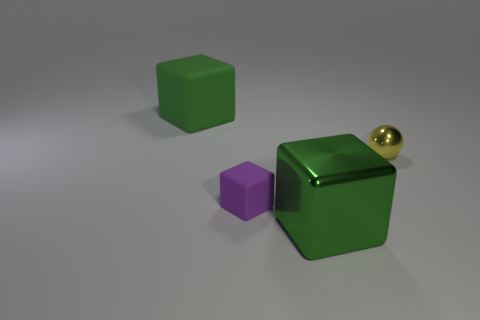Is there anything else that is the same shape as the tiny yellow thing?
Provide a succinct answer. No. Does the object behind the small metal thing have the same shape as the small metal thing?
Provide a succinct answer. No. Is the number of green things that are behind the green shiny cube greater than the number of green metallic objects?
Keep it short and to the point. No. How many small things are both to the left of the green metal object and behind the purple rubber cube?
Offer a very short reply. 0. What color is the rubber block that is in front of the green rubber cube behind the tiny yellow ball?
Offer a terse response. Purple. What number of other blocks are the same color as the large matte block?
Give a very brief answer. 1. Is the color of the small matte cube the same as the cube in front of the small matte block?
Keep it short and to the point. No. Is the number of yellow things less than the number of green blocks?
Provide a short and direct response. Yes. Are there more tiny rubber blocks on the right side of the tiny purple matte object than large cubes on the left side of the metal sphere?
Your answer should be compact. No. Are the purple thing and the ball made of the same material?
Provide a short and direct response. No. 